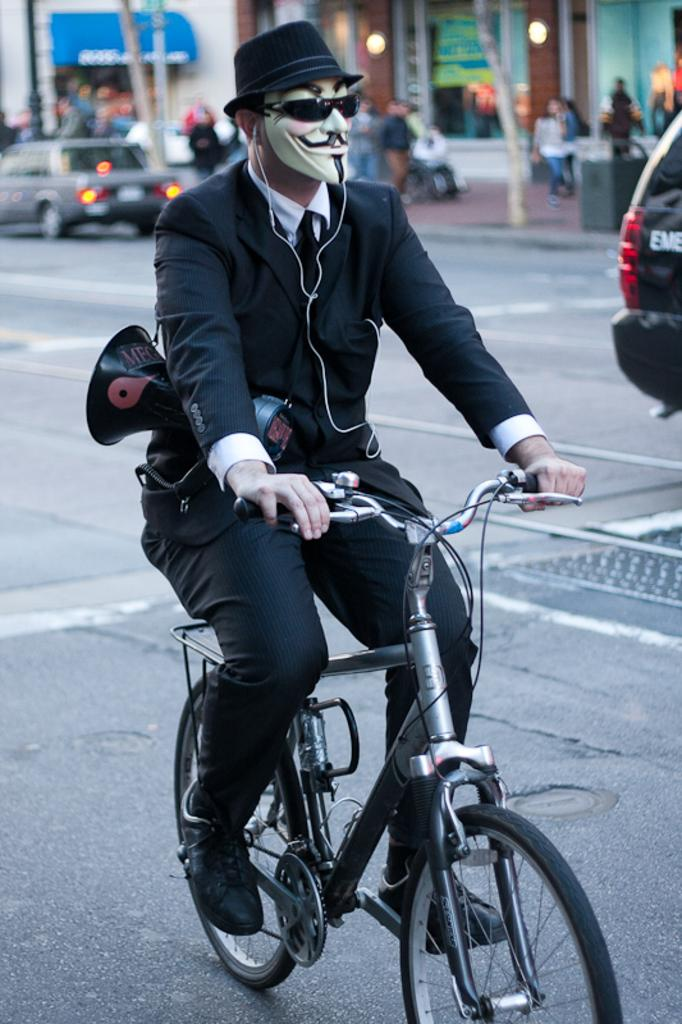What is the man in the image doing? The man is riding a bicycle in the image. What accessories is the man wearing? The man is wearing a hat, a mask, and spectacles in the image. What is the man wearing on his upper body? The man is wearing a blue-colored suit in the image. What additional item does the man have with him? The man has an announcement mic with him in the image. What type of art is the man creating with his chin in the image? There is no art or chin-related activity present in the image; the man is riding a bicycle and has an announcement mic with him. 